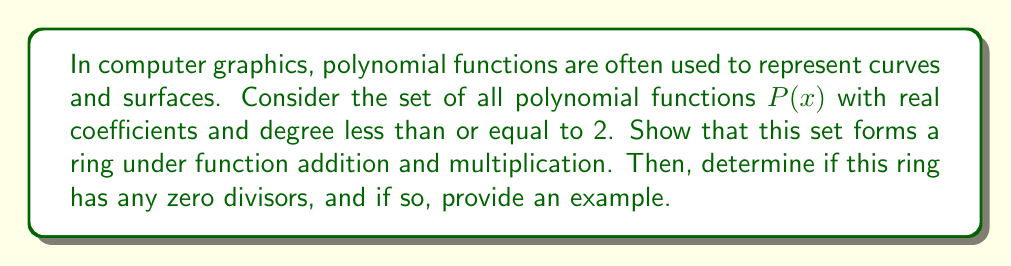What is the answer to this math problem? Let's approach this step-by-step:

1. First, we need to verify that the set of polynomial functions of degree ≤ 2 forms a ring under addition and multiplication.

   A ring $(R, +, \cdot)$ must satisfy these properties:
   a) $(R, +)$ is an abelian group
   b) $(R, \cdot)$ is associative
   c) Distributive laws hold

2. Let $P(x) = a_0 + a_1x + a_2x^2$ and $Q(x) = b_0 + b_1x + b_2x^2$ be two polynomials in our set.

3. Addition: $(P + Q)(x) = (a_0 + b_0) + (a_1 + b_1)x + (a_2 + b_2)x^2$
   This is clearly closed, commutative, and associative. The zero polynomial $0 + 0x + 0x^2$ is the identity, and $-P(x) = -a_0 - a_1x - a_2x^2$ is the additive inverse.

4. Multiplication: $(P \cdot Q)(x) = a_0b_0 + (a_0b_1 + a_1b_0)x + (a_0b_2 + a_1b_1 + a_2b_0)x^2 + (a_1b_2 + a_2b_1)x^3 + a_2b_2x^4$
   This is closed (after truncating to degree 2), associative, and distributive over addition.

5. Therefore, this set forms a ring under these operations.

6. To find zero divisors, we need to find non-zero polynomials $P(x)$ and $Q(x)$ such that $P(x) \cdot Q(x) = 0$ (mod $x^3$).

7. Let $P(x) = x$ and $Q(x) = x^2$. Then $P(x) \cdot Q(x) = x^3 \equiv 0$ (mod $x^3$).

This example is particularly relevant to computer graphics, as it demonstrates how polynomial operations used in curve and surface representations can have unexpected properties when truncated to a specific degree, which is often necessary due to computational constraints.
Answer: Yes, the set of polynomial functions with real coefficients and degree ≤ 2 forms a ring under function addition and multiplication. This ring does have zero divisors. An example of a pair of zero divisors is $P(x) = x$ and $Q(x) = x^2$. 